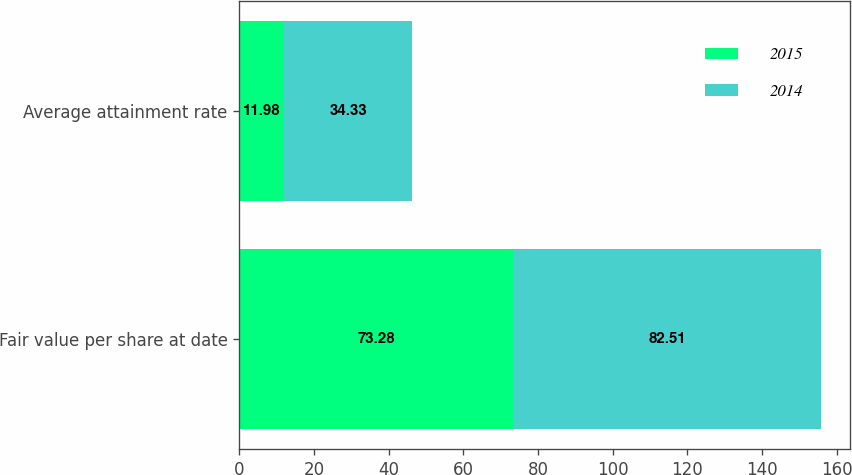Convert chart to OTSL. <chart><loc_0><loc_0><loc_500><loc_500><stacked_bar_chart><ecel><fcel>Fair value per share at date<fcel>Average attainment rate<nl><fcel>2015<fcel>73.28<fcel>11.98<nl><fcel>2014<fcel>82.51<fcel>34.33<nl></chart> 